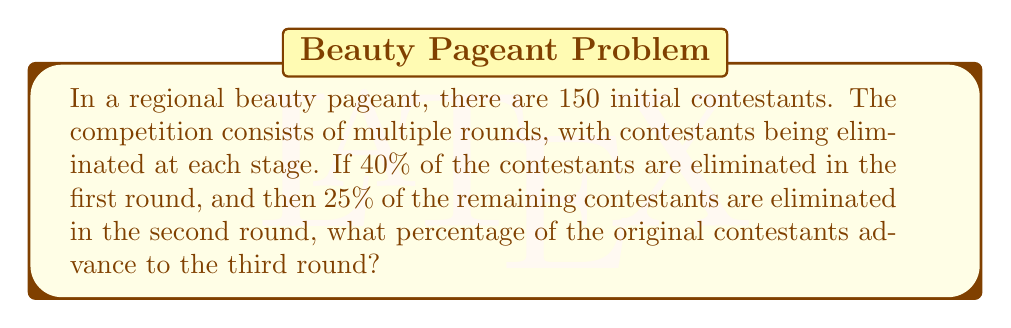Can you solve this math problem? Let's approach this problem step-by-step:

1. Initial number of contestants:
   $N_0 = 150$

2. After the first round:
   - 40% are eliminated, so 60% remain
   - Number of contestants after first round:
     $N_1 = N_0 \times 0.60 = 150 \times 0.60 = 90$

3. After the second round:
   - 25% of the remaining contestants are eliminated, so 75% of $N_1$ advance
   - Number of contestants advancing to the third round:
     $N_2 = N_1 \times 0.75 = 90 \times 0.75 = 67.5$
   - Since we can't have a fractional number of contestants, we round down:
     $N_2 = 67$

4. Calculate the percentage of original contestants advancing:
   $$\text{Percentage} = \frac{\text{Number advancing}}{\text{Original number}} \times 100\%$$
   $$= \frac{67}{150} \times 100\% \approx 44.67\%$$

Therefore, approximately 44.67% of the original contestants advance to the third round.
Answer: 44.67% 